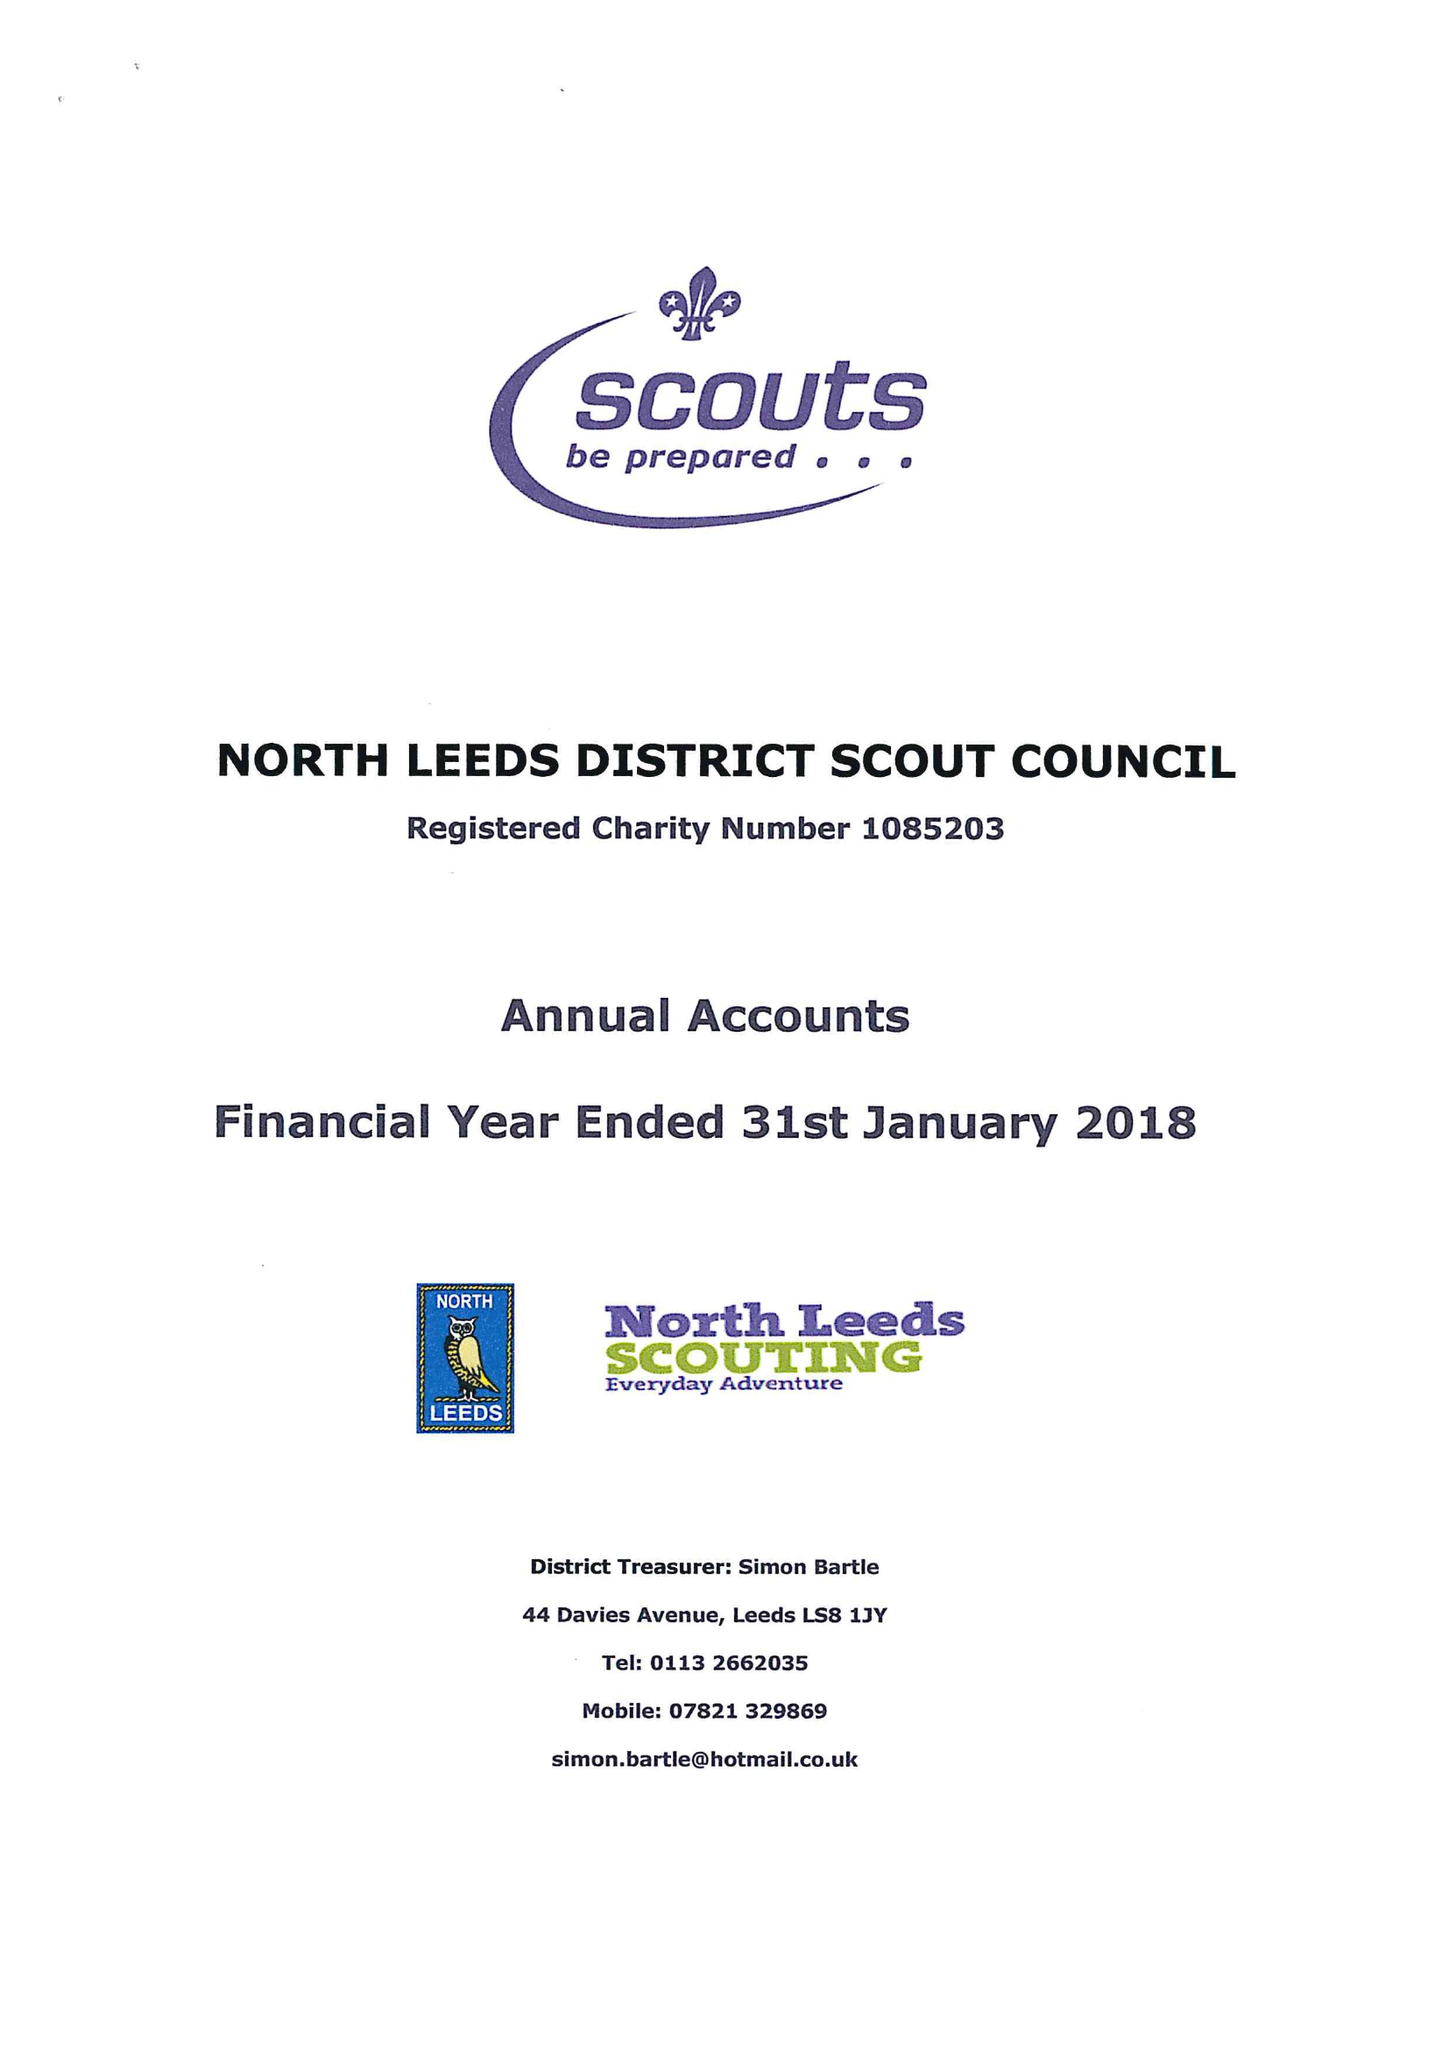What is the value for the spending_annually_in_british_pounds?
Answer the question using a single word or phrase. 152757.00 